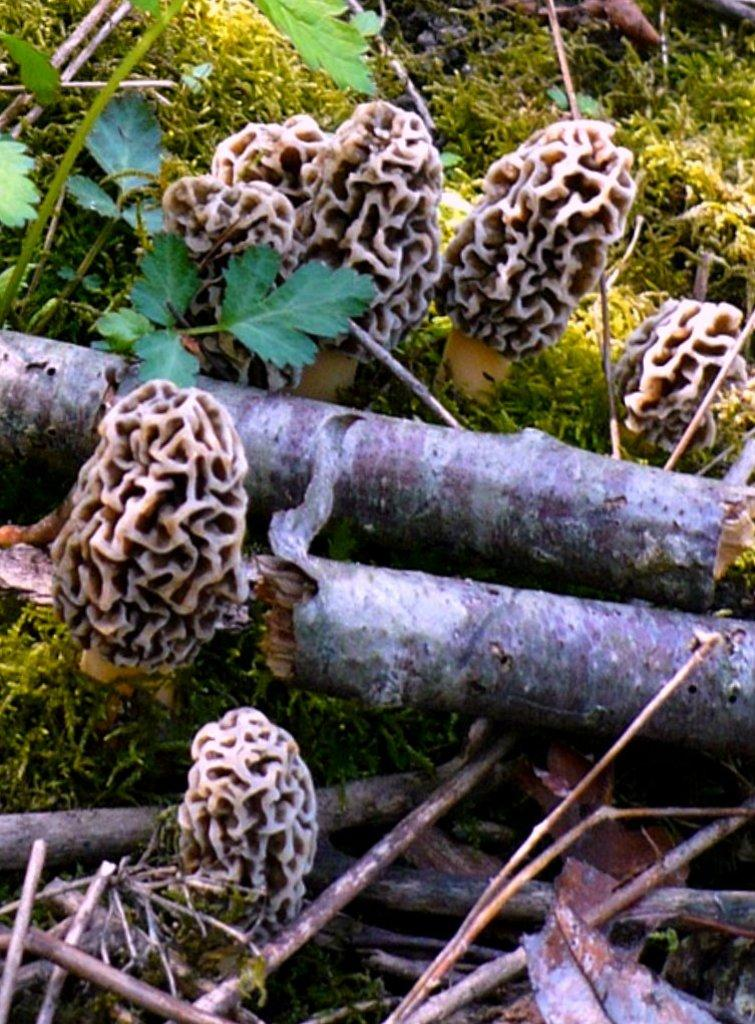What type of plant structure can be seen in the image? There is a tree stem in the image. What type of vegetation is present in the image? There is grass in the image. What other types of plants can be seen in the image? There are plants in the image. What is the creator's name of the brass sculpture in the image? There is no brass sculpture present in the image. 